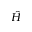Convert formula to latex. <formula><loc_0><loc_0><loc_500><loc_500>\hat { H }</formula> 